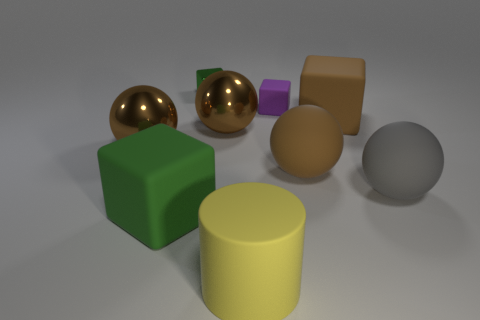How many brown spheres must be subtracted to get 1 brown spheres? 2 Subtract all gray cubes. How many brown spheres are left? 3 Subtract all brown blocks. How many blocks are left? 3 Subtract all large brown rubber spheres. How many spheres are left? 3 Subtract all yellow blocks. Subtract all cyan spheres. How many blocks are left? 4 Add 1 large yellow matte cylinders. How many objects exist? 10 Subtract all cubes. How many objects are left? 5 Subtract all red matte things. Subtract all large brown things. How many objects are left? 5 Add 9 large cylinders. How many large cylinders are left? 10 Add 8 tiny gray metal spheres. How many tiny gray metal spheres exist? 8 